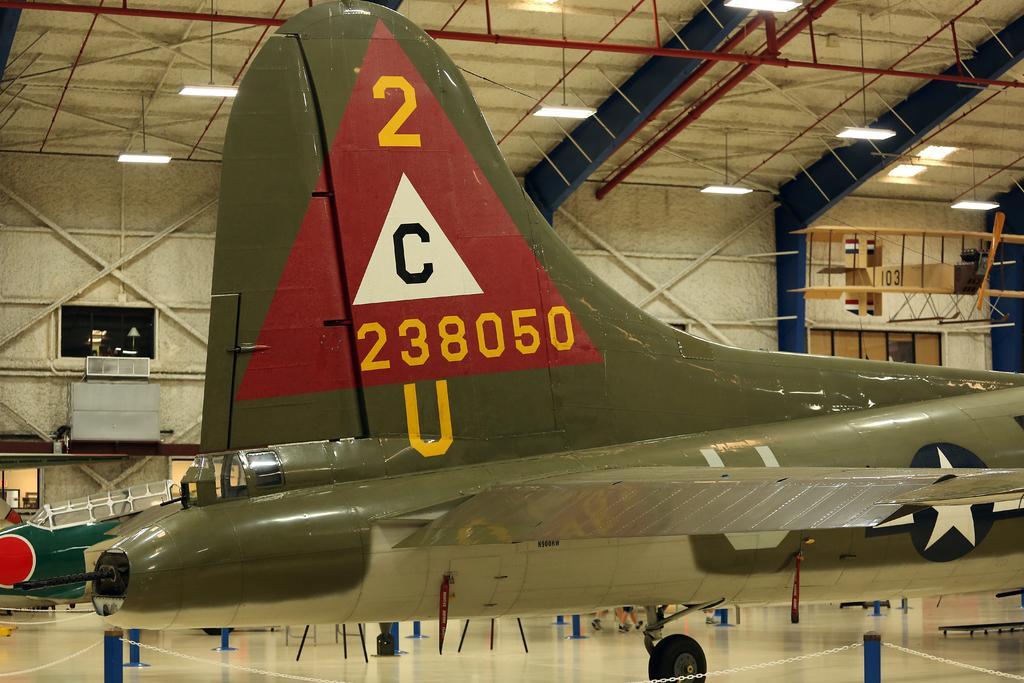<image>
Summarize the visual content of the image. A large green and red military airplane in a hangar. 